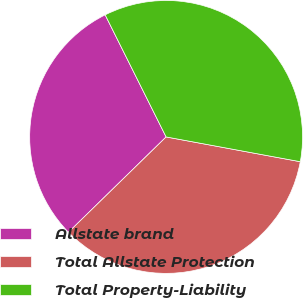<chart> <loc_0><loc_0><loc_500><loc_500><pie_chart><fcel>Allstate brand<fcel>Total Allstate Protection<fcel>Total Property-Liability<nl><fcel>29.94%<fcel>34.79%<fcel>35.28%<nl></chart> 